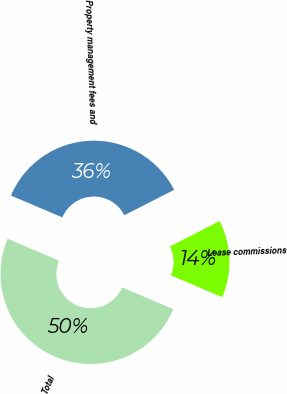Convert chart. <chart><loc_0><loc_0><loc_500><loc_500><pie_chart><fcel>Lease commissions<fcel>Property management fees and<fcel>Total<nl><fcel>13.89%<fcel>36.11%<fcel>50.0%<nl></chart> 